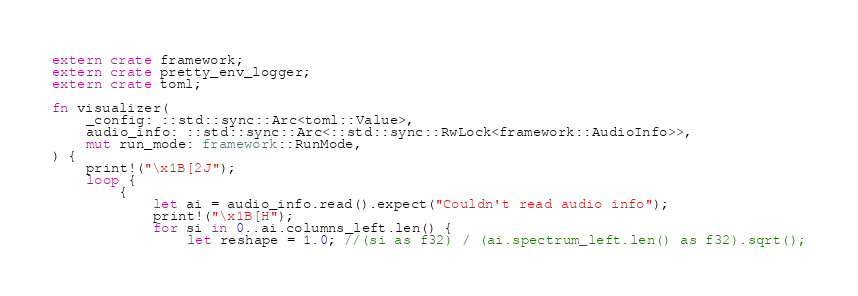Convert code to text. <code><loc_0><loc_0><loc_500><loc_500><_Rust_>extern crate framework;
extern crate pretty_env_logger;
extern crate toml;

fn visualizer(
    _config: ::std::sync::Arc<toml::Value>,
    audio_info: ::std::sync::Arc<::std::sync::RwLock<framework::AudioInfo>>,
    mut run_mode: framework::RunMode,
) {
    print!("\x1B[2J");
    loop {
        {
            let ai = audio_info.read().expect("Couldn't read audio info");
            print!("\x1B[H");
            for si in 0..ai.columns_left.len() {
                let reshape = 1.0; //(si as f32) / (ai.spectrum_left.len() as f32).sqrt();</code> 